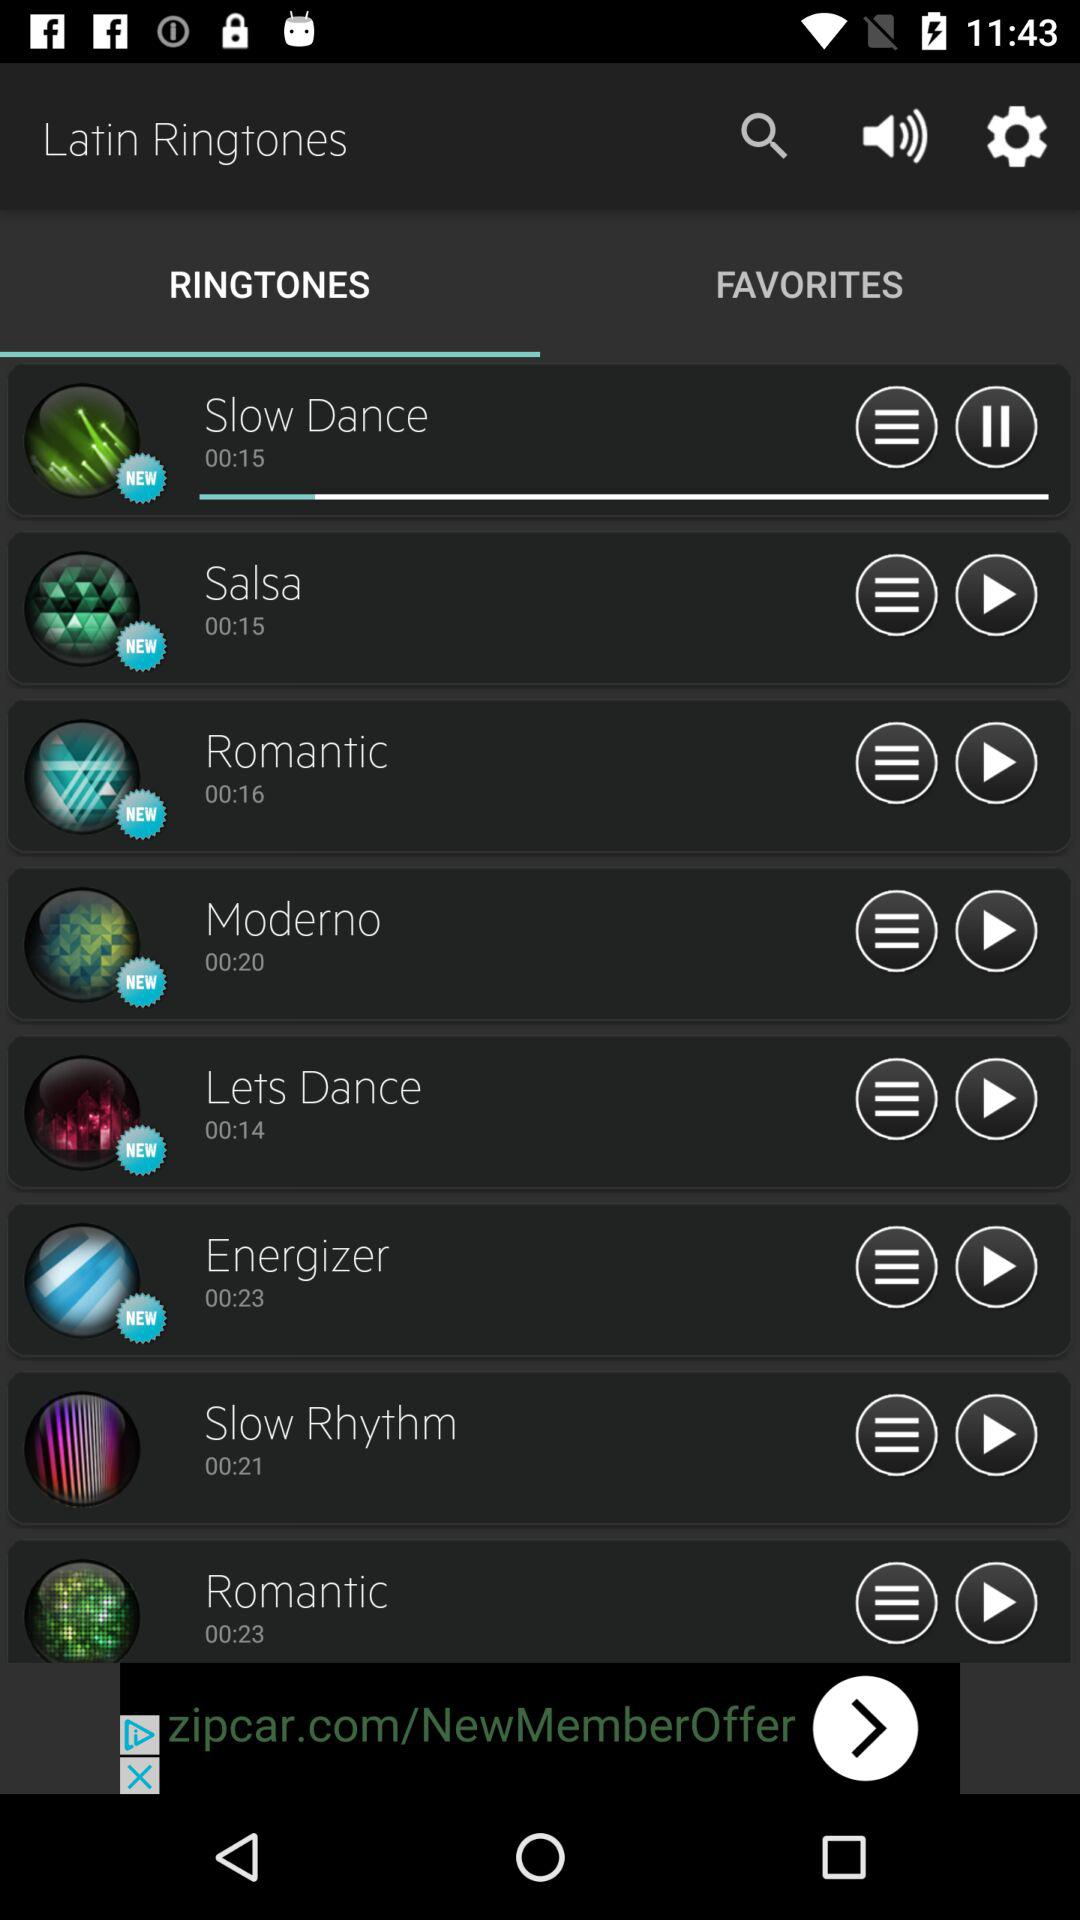What is the duration of Salsa? The duration is 00:15. 